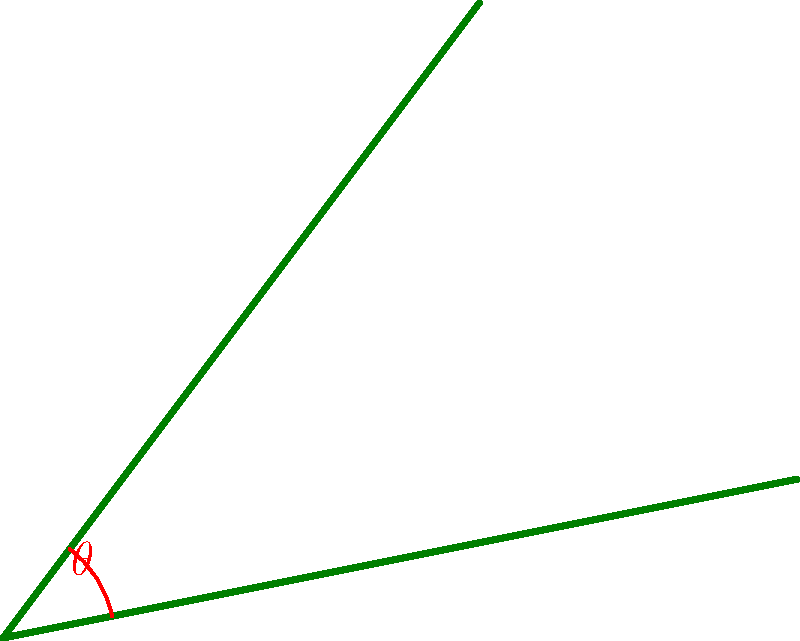In your forest-inspired oil painting, you've depicted two intersecting tree branches. The branches form an angle $\theta$ at their point of intersection. Given that one branch extends from the point of intersection to a point 3 units east and 4 units north, while the other branch extends to a point 5 units east and 1 unit north from the intersection, calculate the angle $\theta$ between these branches to the nearest degree. To find the angle between the two branches, we can follow these steps:

1) First, let's consider the two branches as vectors:
   Vector 1: $\vec{v_1} = (3, 4)$
   Vector 2: $\vec{v_2} = (5, 1)$

2) We can use the dot product formula to find the angle between these vectors:
   $\cos \theta = \frac{\vec{v_1} \cdot \vec{v_2}}{|\vec{v_1}||\vec{v_2}|}$

3) Calculate the dot product $\vec{v_1} \cdot \vec{v_2}$:
   $\vec{v_1} \cdot \vec{v_2} = (3 \times 5) + (4 \times 1) = 15 + 4 = 19$

4) Calculate the magnitudes of the vectors:
   $|\vec{v_1}| = \sqrt{3^2 + 4^2} = \sqrt{25} = 5$
   $|\vec{v_2}| = \sqrt{5^2 + 1^2} = \sqrt{26}$

5) Substitute into the formula:
   $\cos \theta = \frac{19}{5\sqrt{26}}$

6) Take the inverse cosine (arccos) of both sides:
   $\theta = \arccos(\frac{19}{5\sqrt{26}})$

7) Calculate this value and convert to degrees:
   $\theta \approx 0.7850 \text{ radians} \approx 44.97°$

8) Rounding to the nearest degree:
   $\theta \approx 45°$
Answer: 45° 